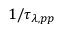<formula> <loc_0><loc_0><loc_500><loc_500>1 / \tau _ { \lambda , p p }</formula> 